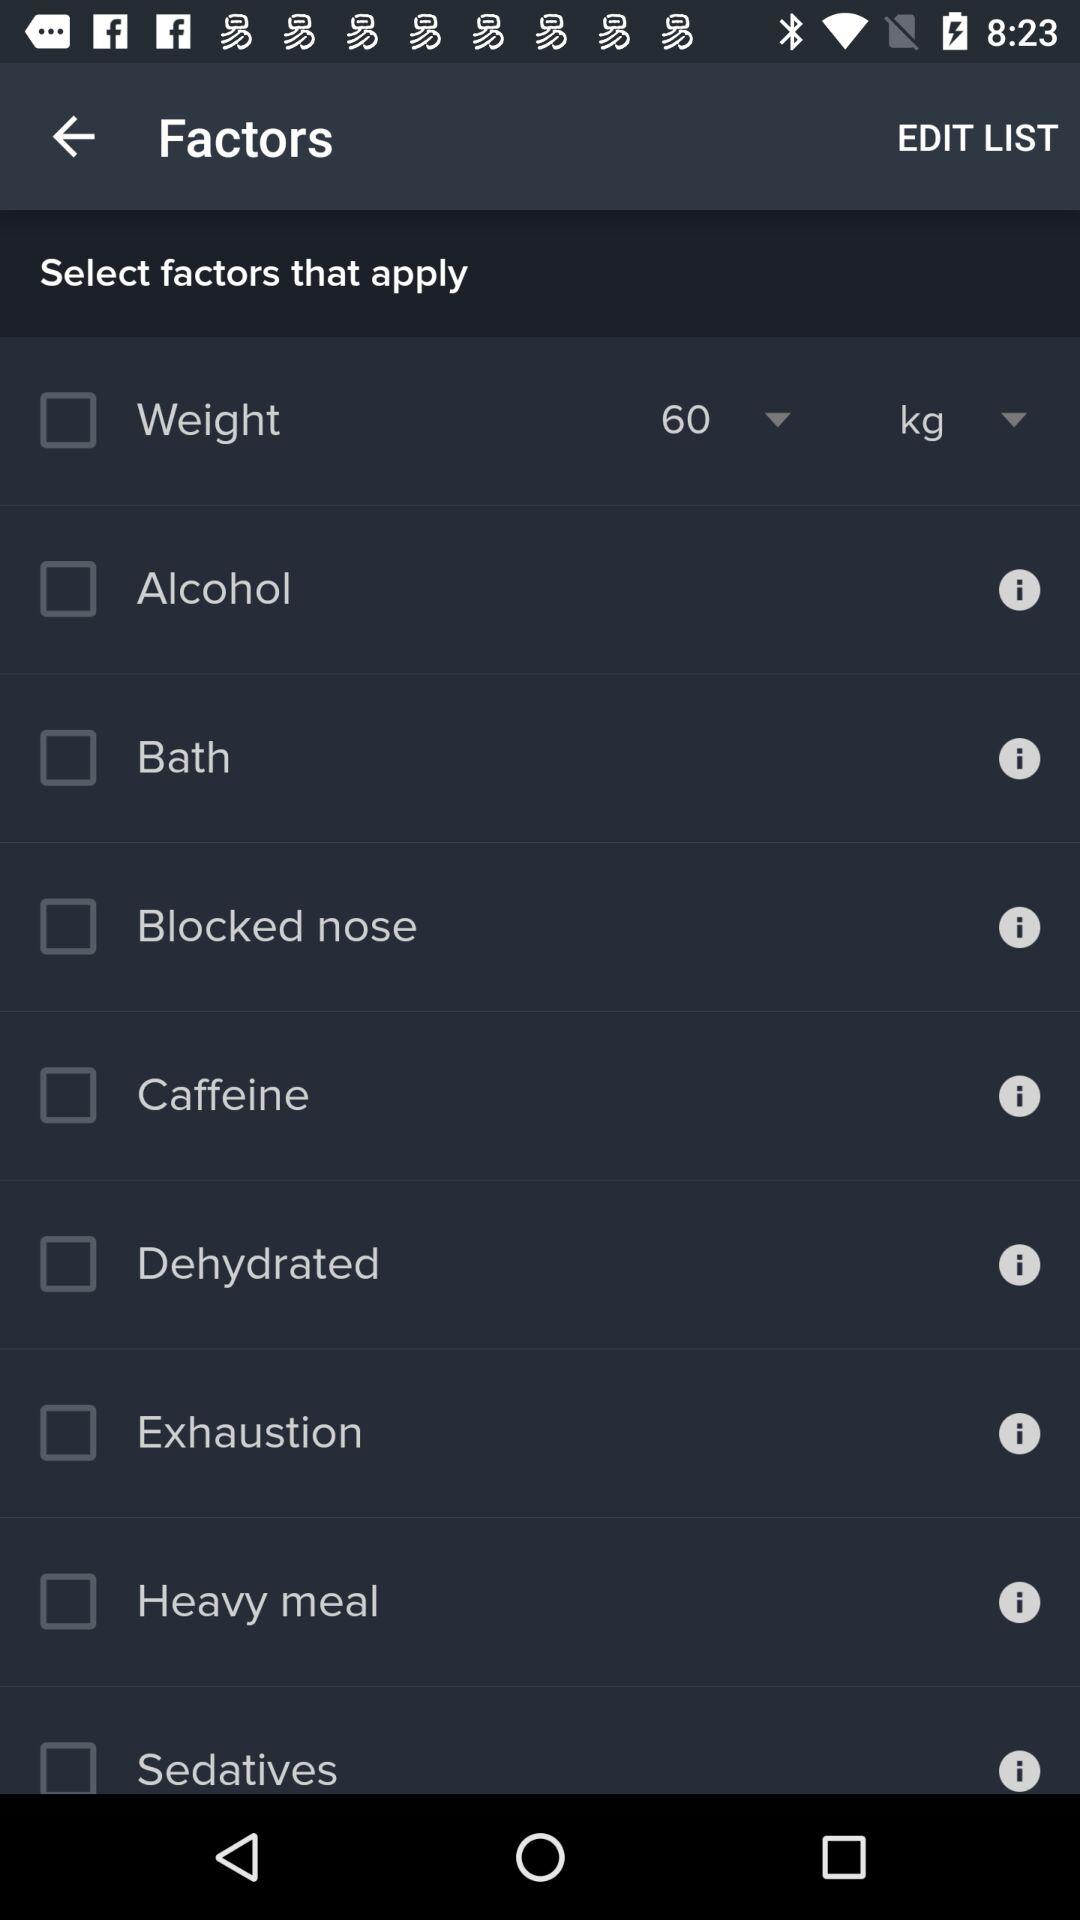What's the status of "Alcohol"? The status is "off". 